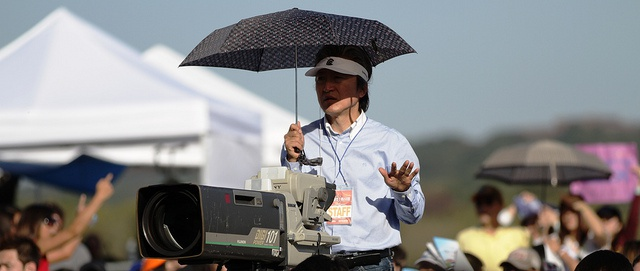Describe the objects in this image and their specific colors. I can see people in darkgray, lightgray, black, and gray tones, umbrella in darkgray, black, and gray tones, umbrella in darkgray, gray, and black tones, people in darkgray, gray, black, maroon, and brown tones, and people in darkgray, gray, black, and maroon tones in this image. 